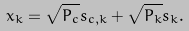<formula> <loc_0><loc_0><loc_500><loc_500>x _ { k } = \sqrt { P _ { c } } s _ { c , k } + \sqrt { P _ { k } } s _ { k } .</formula> 